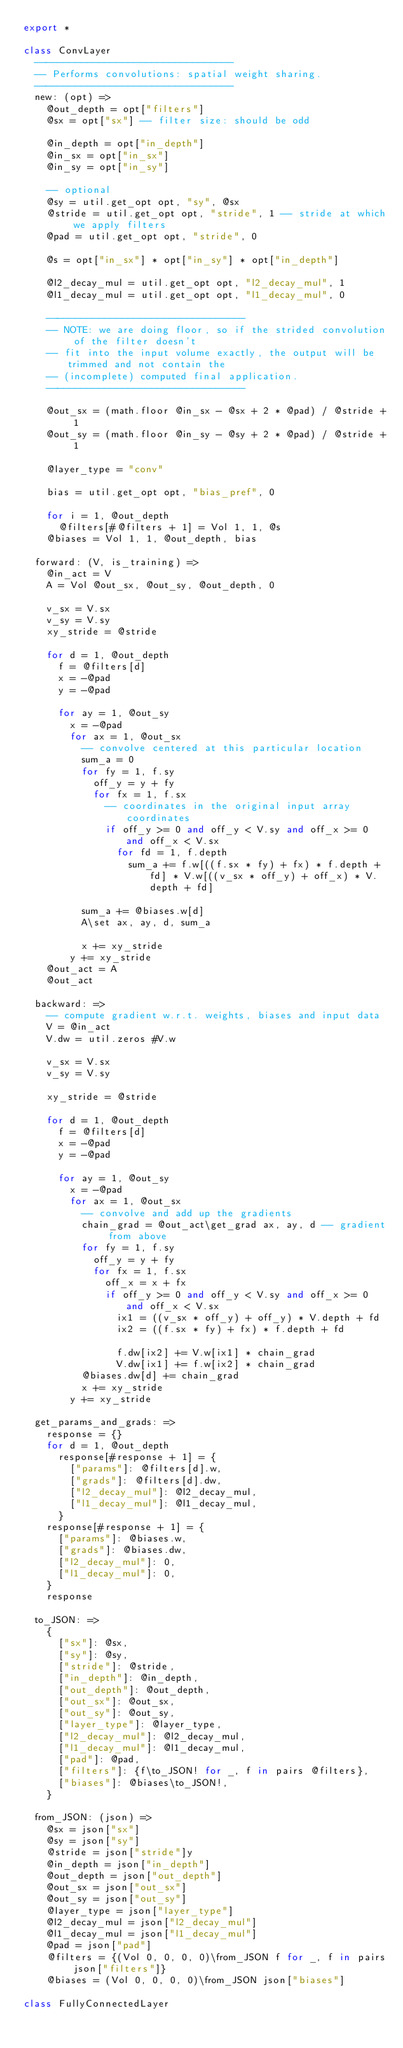<code> <loc_0><loc_0><loc_500><loc_500><_MoonScript_>export *

class ConvLayer
  ----------------------------------
  -- Performs convolutions: spatial weight sharing.
  ----------------------------------
  new: (opt) =>
    @out_depth = opt["filters"]
    @sx = opt["sx"] -- filter size: should be odd

    @in_depth = opt["in_depth"]
    @in_sx = opt["in_sx"]
    @in_sy = opt["in_sy"]

    -- optional
    @sy = util.get_opt opt, "sy", @sx
    @stride = util.get_opt opt, "stride", 1 -- stride at which we apply filters
    @pad = util.get_opt opt, "stride", 0

    @s = opt["in_sx"] * opt["in_sy"] * opt["in_depth"]

    @l2_decay_mul = util.get_opt opt, "l2_decay_mul", 1
    @l1_decay_mul = util.get_opt opt, "l1_decay_mul", 0

    ----------------------------------
    -- NOTE: we are doing floor, so if the strided convolution of the filter doesn't
    -- fit into the input volume exactly, the output will be trimmed and not contain the
    -- (incomplete) computed final application.
    ----------------------------------

    @out_sx = (math.floor @in_sx - @sx + 2 * @pad) / @stride + 1
    @out_sy = (math.floor @in_sy - @sy + 2 * @pad) / @stride + 1

    @layer_type = "conv"

    bias = util.get_opt opt, "bias_pref", 0

    for i = 1, @out_depth
      @filters[#@filters + 1] = Vol 1, 1, @s
    @biases = Vol 1, 1, @out_depth, bias

  forward: (V, is_training) =>
    @in_act = V
    A = Vol @out_sx, @out_sy, @out_depth, 0

    v_sx = V.sx
    v_sy = V.sy
    xy_stride = @stride

    for d = 1, @out_depth
      f = @filters[d]
      x = -@pad
      y = -@pad

      for ay = 1, @out_sy
        x = -@pad
        for ax = 1, @out_sx
          -- convolve centered at this particular location
          sum_a = 0
          for fy = 1, f.sy
            off_y = y + fy
            for fx = 1, f.sx
              -- coordinates in the original input array coordinates
              if off_y >= 0 and off_y < V.sy and off_x >= 0 and off_x < V.sx
                for fd = 1, f.depth
                  sum_a += f.w[((f.sx * fy) + fx) * f.depth + fd] * V.w[((v_sx * off_y) + off_x) * V.depth + fd]

          sum_a += @biases.w[d]
          A\set ax, ay, d, sum_a

          x += xy_stride
        y += xy_stride
    @out_act = A
    @out_act

  backward: =>
    -- compute gradient w.r.t. weights, biases and input data
    V = @in_act
    V.dw = util.zeros #V.w

    v_sx = V.sx
    v_sy = V.sy

    xy_stride = @stride

    for d = 1, @out_depth
      f = @filters[d]
      x = -@pad
      y = -@pad

      for ay = 1, @out_sy
        x = -@pad
        for ax = 1, @out_sx
          -- convolve and add up the gradients
          chain_grad = @out_act\get_grad ax, ay, d -- gradient from above
          for fy = 1, f.sy
            off_y = y + fy
            for fx = 1, f.sx
              off_x = x + fx
              if off_y >= 0 and off_y < V.sy and off_x >= 0 and off_x < V.sx
                ix1 = ((v_sx * off_y) + off_y) * V.depth + fd
                ix2 = ((f.sx * fy) + fx) * f.depth + fd

                f.dw[ix2] += V.w[ix1] * chain_grad
                V.dw[ix1] += f.w[ix2] * chain_grad
          @biases.dw[d] += chain_grad
          x += xy_stride
        y += xy_stride

  get_params_and_grads: =>
    response = {}
    for d = 1, @out_depth
      response[#response + 1] = {
        ["params"]: @filters[d].w,
        ["grads"]: @filters[d].dw,
        ["l2_decay_mul"]: @l2_decay_mul,
        ["l1_decay_mul"]: @l1_decay_mul,
      }
    response[#response + 1] = {
      ["params"]: @biases.w,
      ["grads"]: @biases.dw,
      ["l2_decay_mul"]: 0,
      ["l1_decay_mul"]: 0,
    }
    response

  to_JSON: =>
    {
      ["sx"]: @sx,
      ["sy"]: @sy,
      ["stride"]: @stride,
      ["in_depth"]: @in_depth,
      ["out_depth"]: @out_depth,
      ["out_sx"]: @out_sx,
      ["out_sy"]: @out_sy,
      ["layer_type"]: @layer_type,
      ["l2_decay_mul"]: @l2_decay_mul,
      ["l1_decay_mul"]: @l1_decay_mul,
      ["pad"]: @pad,
      ["filters"]: {f\to_JSON! for _, f in pairs @filters},
      ["biases"]: @biases\to_JSON!,
    }

  from_JSON: (json) =>
    @sx = json["sx"]
    @sy = json["sy"]
    @stride = json["stride"]y
    @in_depth = json["in_depth"]
    @out_depth = json["out_depth"]
    @out_sx = json["out_sx"]
    @out_sy = json["out_sy"]
    @layer_type = json["layer_type"]
    @l2_decay_mul = json["l2_decay_mul"]
    @l1_decay_mul = json["l1_decay_mul"]
    @pad = json["pad"]
    @filters = {(Vol 0, 0, 0, 0)\from_JSON f for _, f in pairs json["filters"]}
    @biases = (Vol 0, 0, 0, 0)\from_JSON json["biases"]

class FullyConnectedLayer</code> 